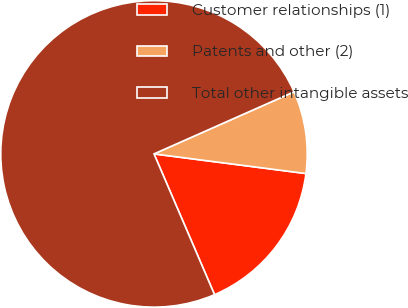<chart> <loc_0><loc_0><loc_500><loc_500><pie_chart><fcel>Customer relationships (1)<fcel>Patents and other (2)<fcel>Total other intangible assets<nl><fcel>16.49%<fcel>8.69%<fcel>74.82%<nl></chart> 